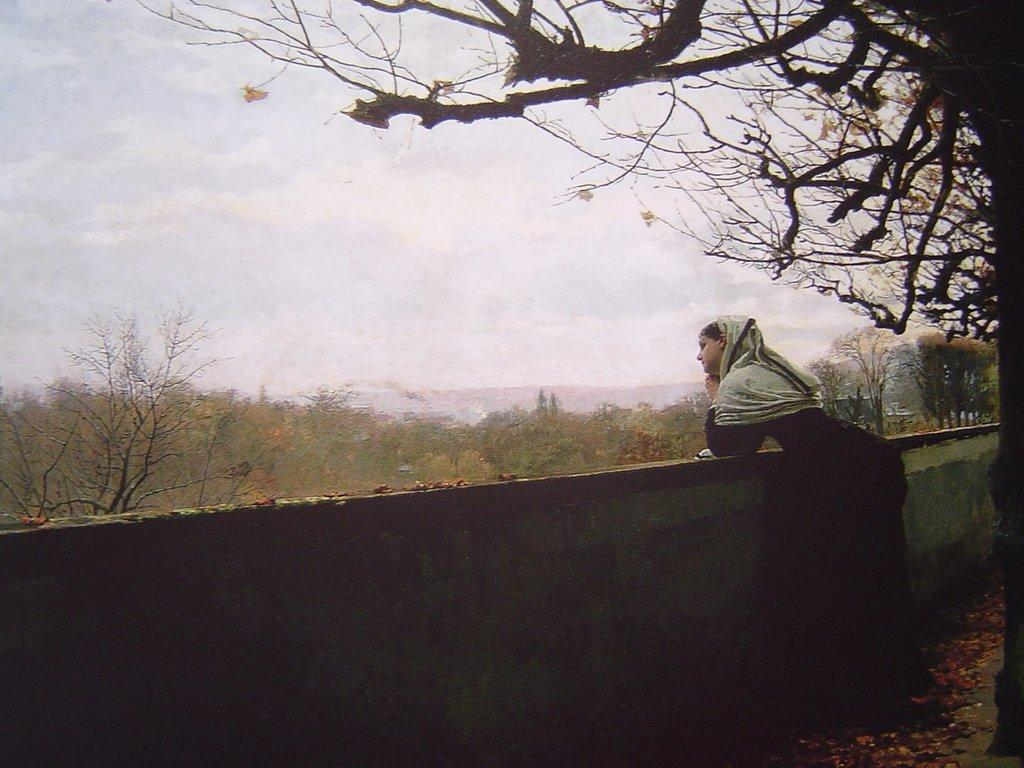What is the main subject of the image? There is a woman standing in the image. Where is the woman positioned in the image? The woman is standing at a wall. What can be seen on the ground in the image? Dried leaves are present on the ground. What type of natural environment is visible in the image? There are trees visible in the image, and the sky is visible in the background. What type of quiver can be seen hanging from the woman's leg in the image? There is no quiver present in the image, nor is there any indication that the woman has a leg visible. 